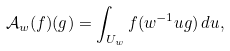Convert formula to latex. <formula><loc_0><loc_0><loc_500><loc_500>\mathcal { A } _ { w } ( f ) ( g ) = \int _ { U _ { w } } f ( w ^ { - 1 } u g ) \, d u ,</formula> 